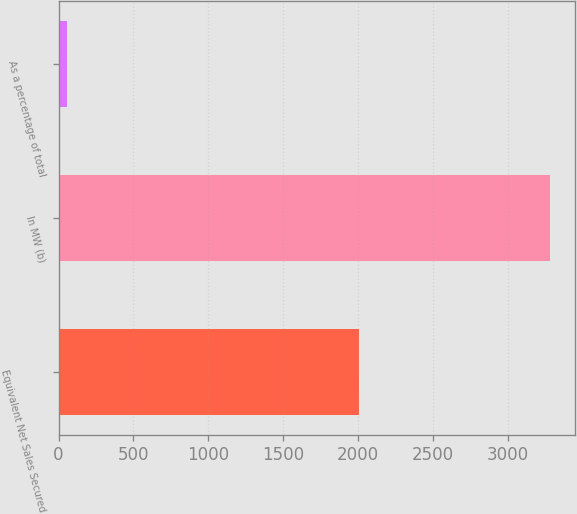<chart> <loc_0><loc_0><loc_500><loc_500><bar_chart><fcel>Equivalent Net Sales Secured<fcel>In MW (b)<fcel>As a percentage of total<nl><fcel>2008<fcel>3283<fcel>57<nl></chart> 